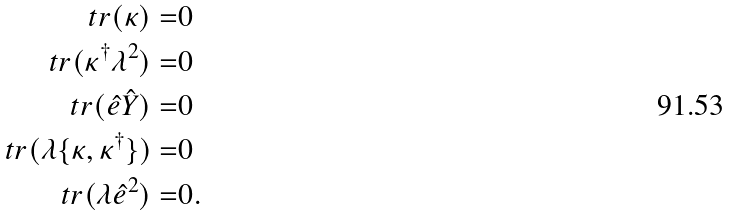Convert formula to latex. <formula><loc_0><loc_0><loc_500><loc_500>t r ( \kappa ) = & 0 \\ t r ( \kappa ^ { \dagger } \lambda ^ { 2 } ) = & 0 \\ \ t r ( \hat { e } \hat { Y } ) = & 0 \\ \ t r ( \lambda \{ \kappa , \kappa ^ { \dagger } \} ) = & 0 \\ \ t r ( \lambda \hat { e } ^ { 2 } ) = & 0 .</formula> 